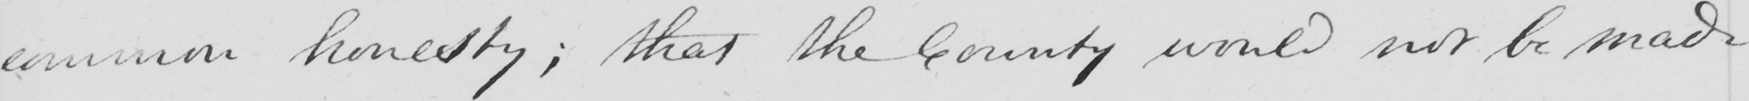What text is written in this handwritten line? common honesty ; that the County would not be made 